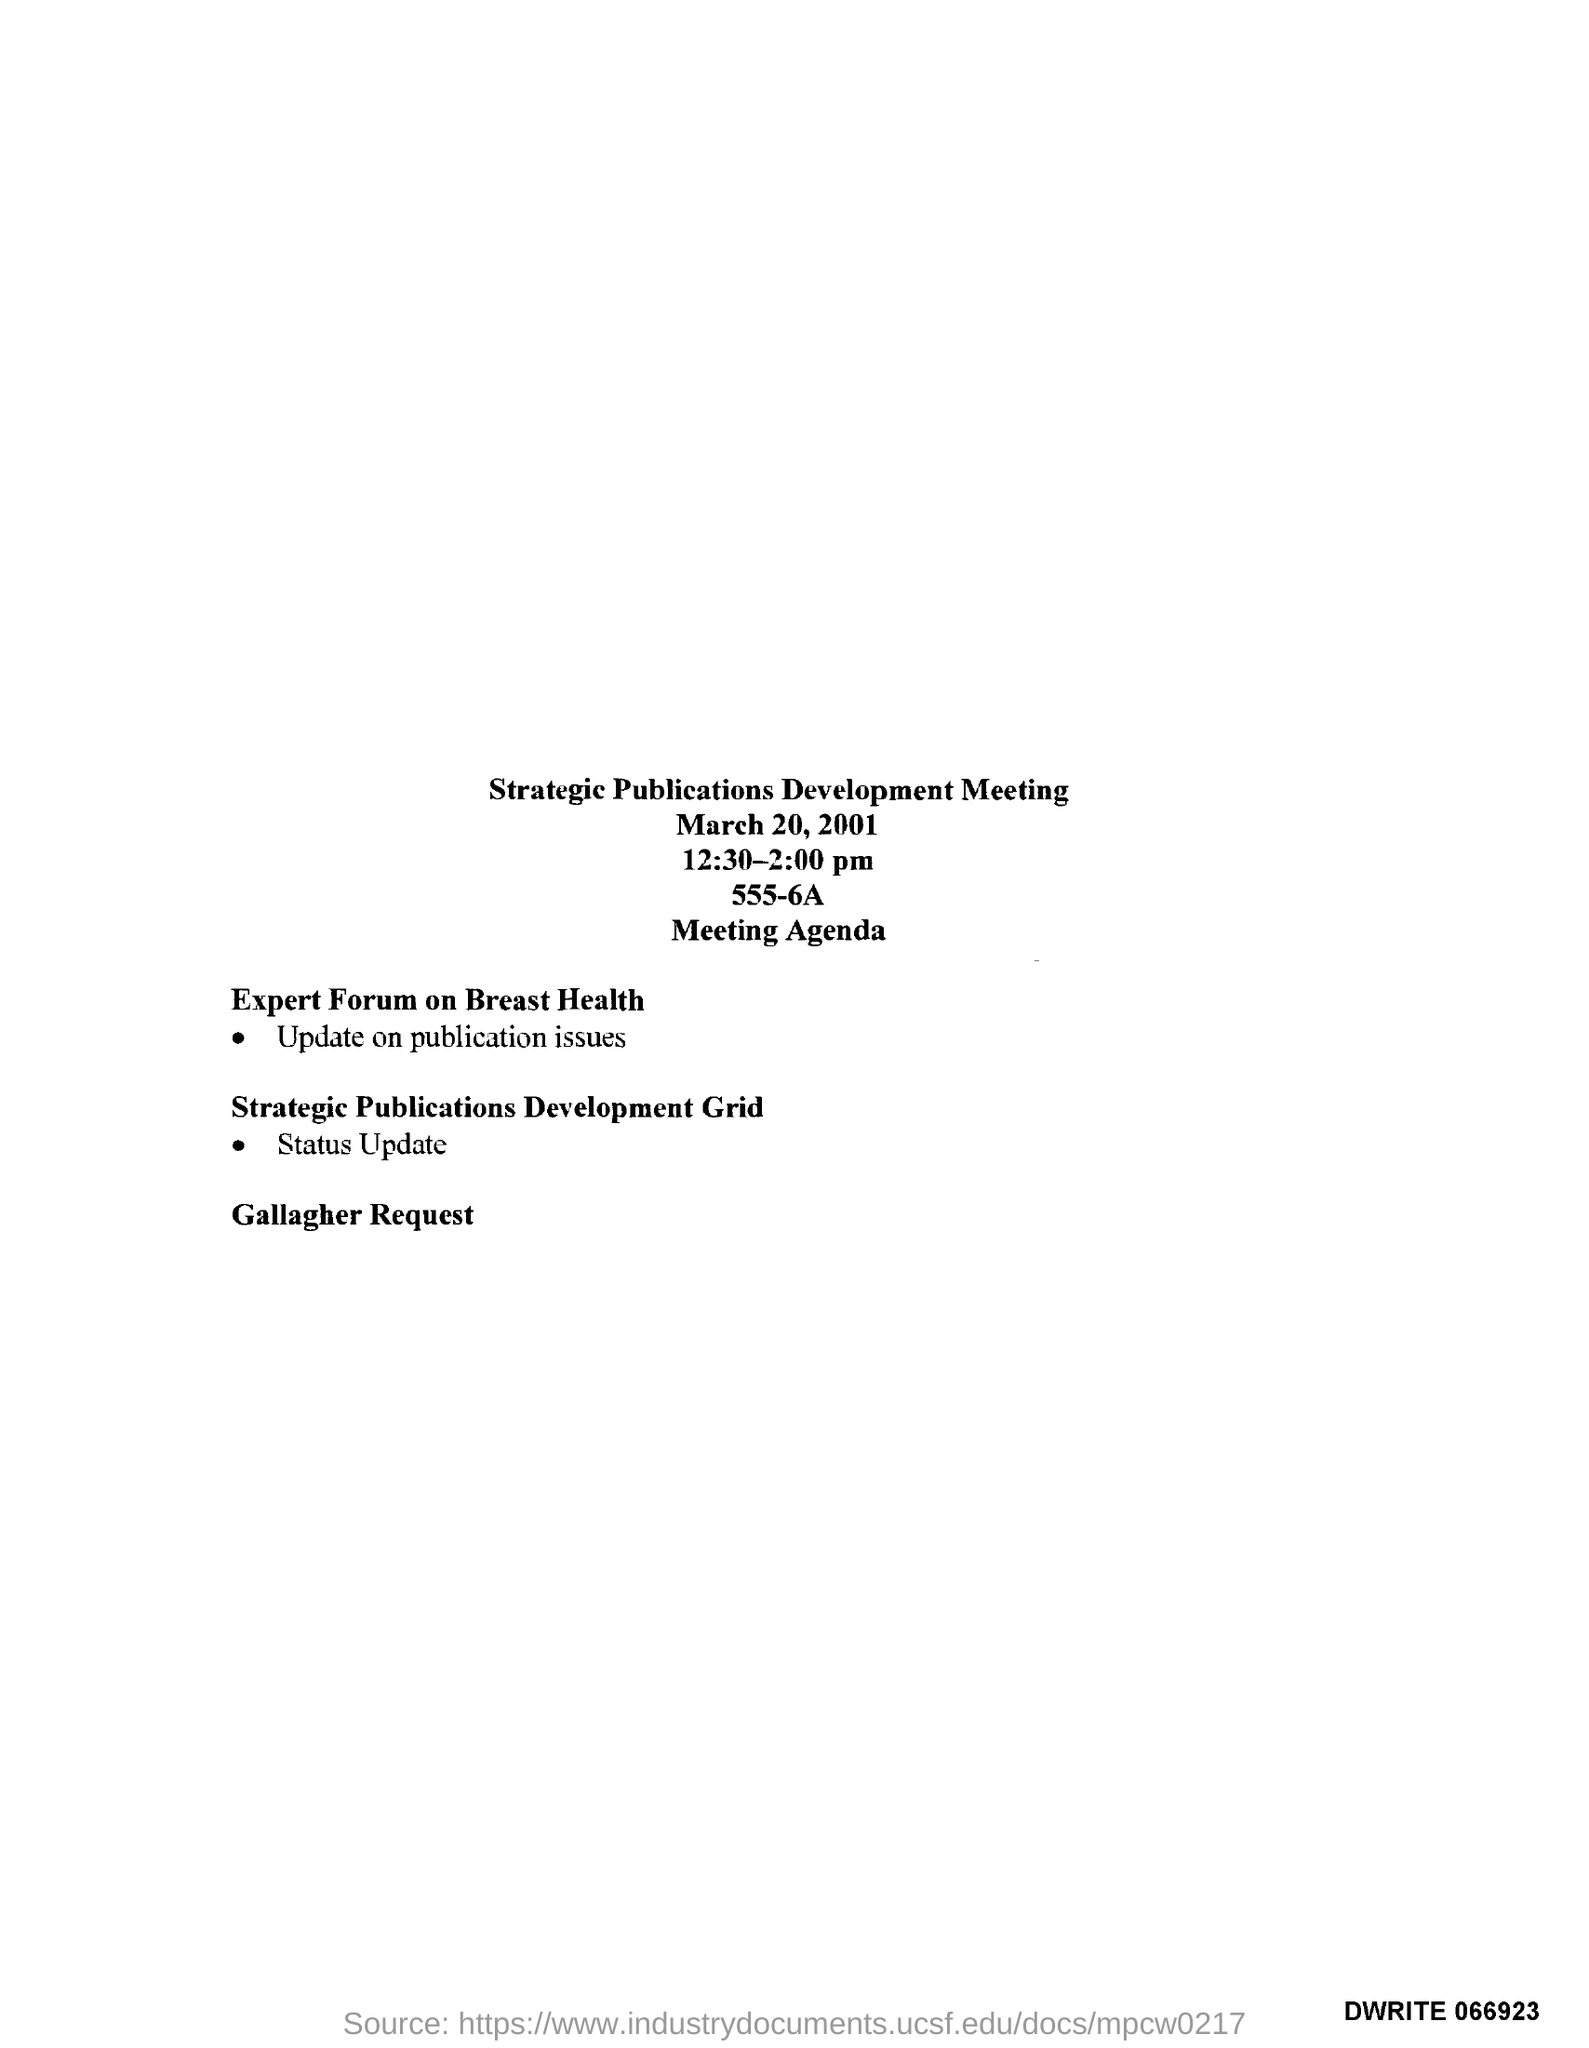Identify some key points in this picture. The meeting's title was 'Strategic Publications Development.' The timing of the meeting is from 12:30 pm to 2:00 pm. The date mentioned in the top of the document is March 20, 2001. 